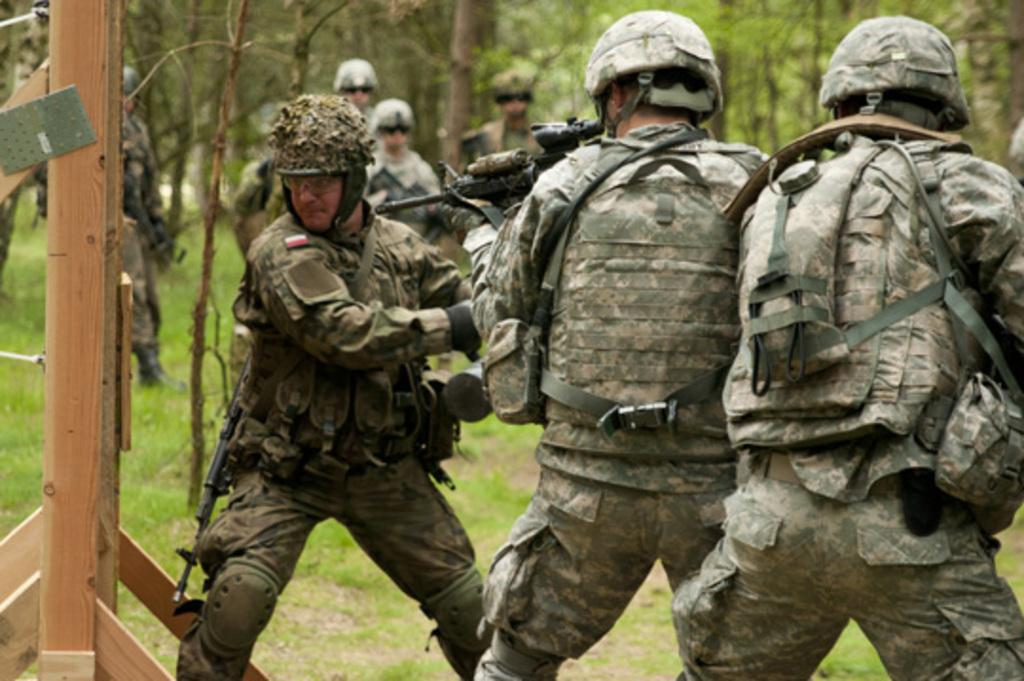How many people are present in the image? There are three people standing in the image. What is one person holding in the image? One person is holding a weapon. What can be seen in the background of the image? There are people standing in the background of the image. What type of vegetation is visible in the image? There is grass visible in the image. What architectural feature can be seen in the image? There is a wooden pillar in the image. What type of crib is visible in the image? There is no crib present in the image. What type of medical advice can be given by the doctor in the image? There is no doctor present in the image. 